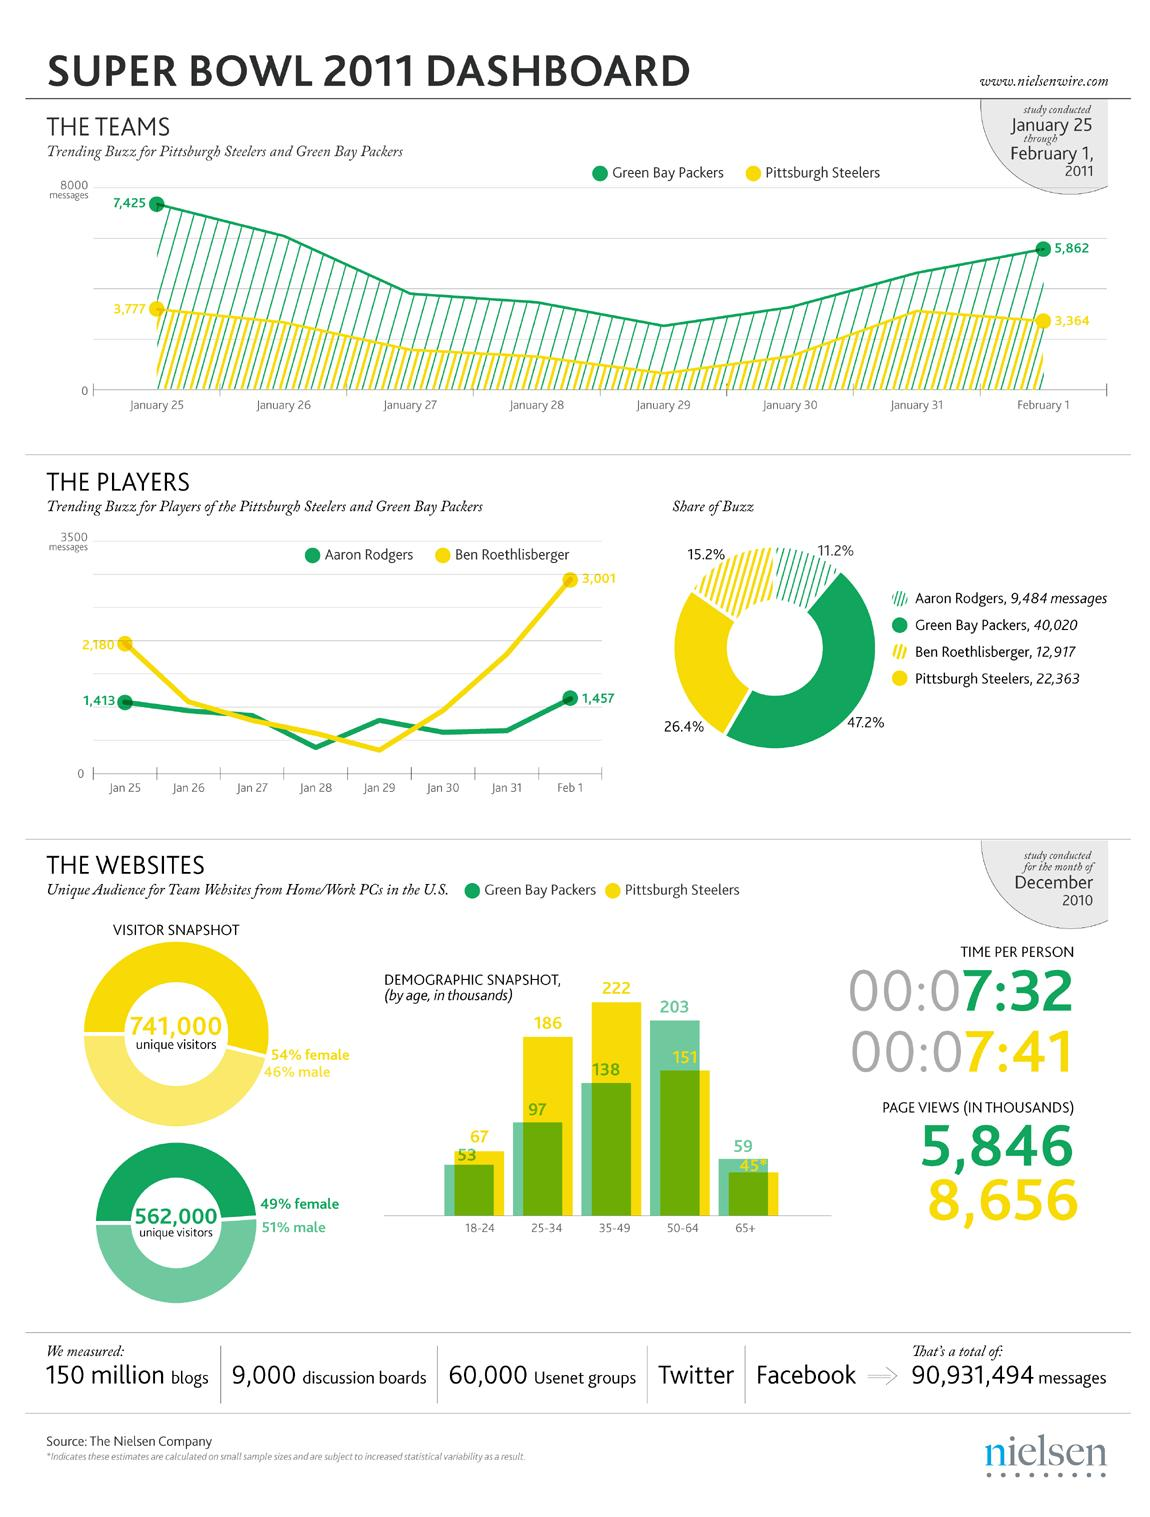Point out several critical features in this image. The media buzz surrounding the Green Bay Packers is 47.2%. The media buzz of Ben is 15.2%. On February 1st, Ben received more messages than he did on January 25th. Specifically, he received 821 additional messages on February 1st. It is Ben who is closer to reaching 3500 messages. On January 25, a total of 2,180 messages were received for Ben. 